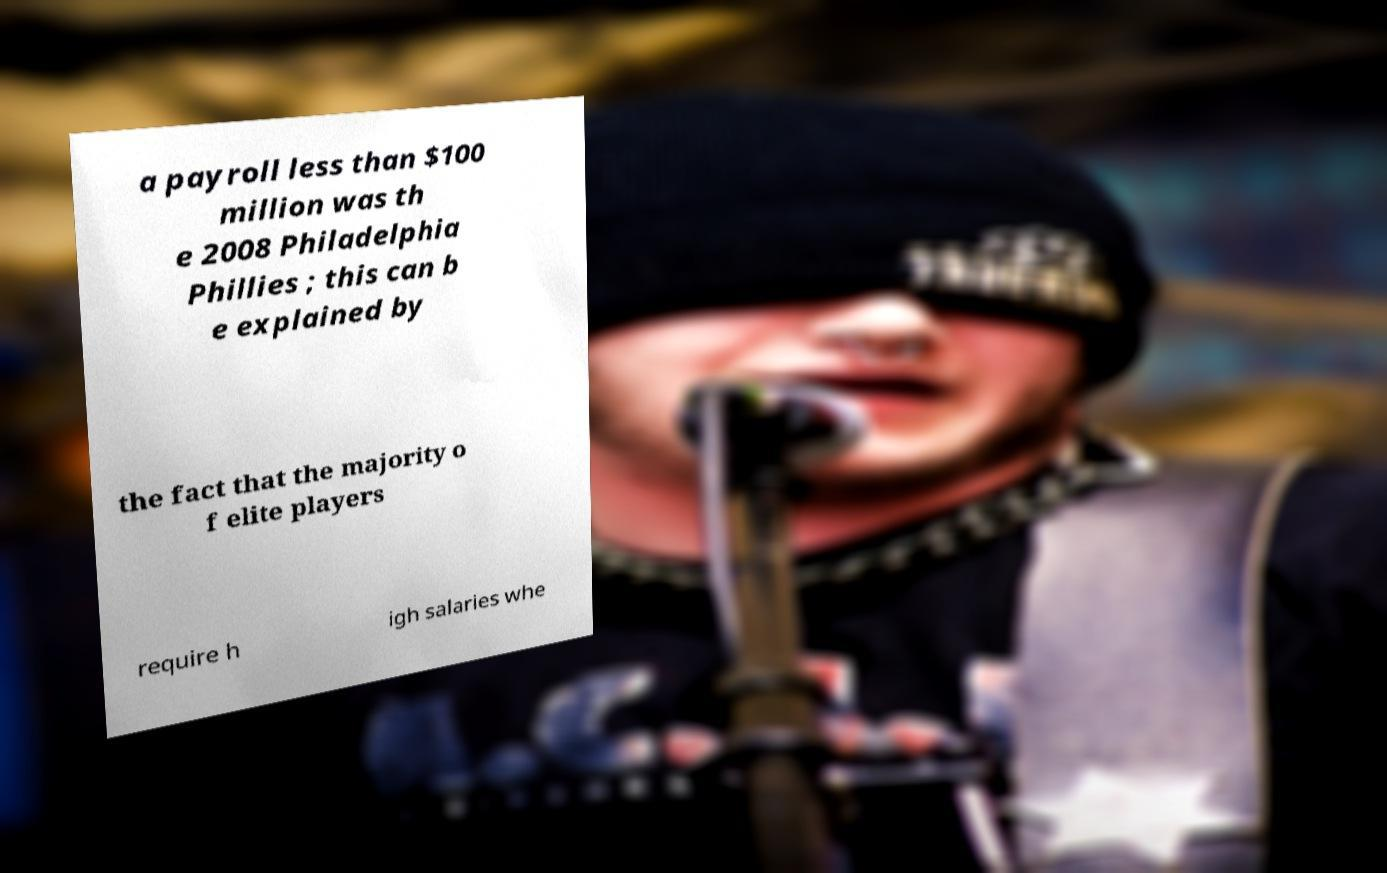Could you assist in decoding the text presented in this image and type it out clearly? a payroll less than $100 million was th e 2008 Philadelphia Phillies ; this can b e explained by the fact that the majority o f elite players require h igh salaries whe 